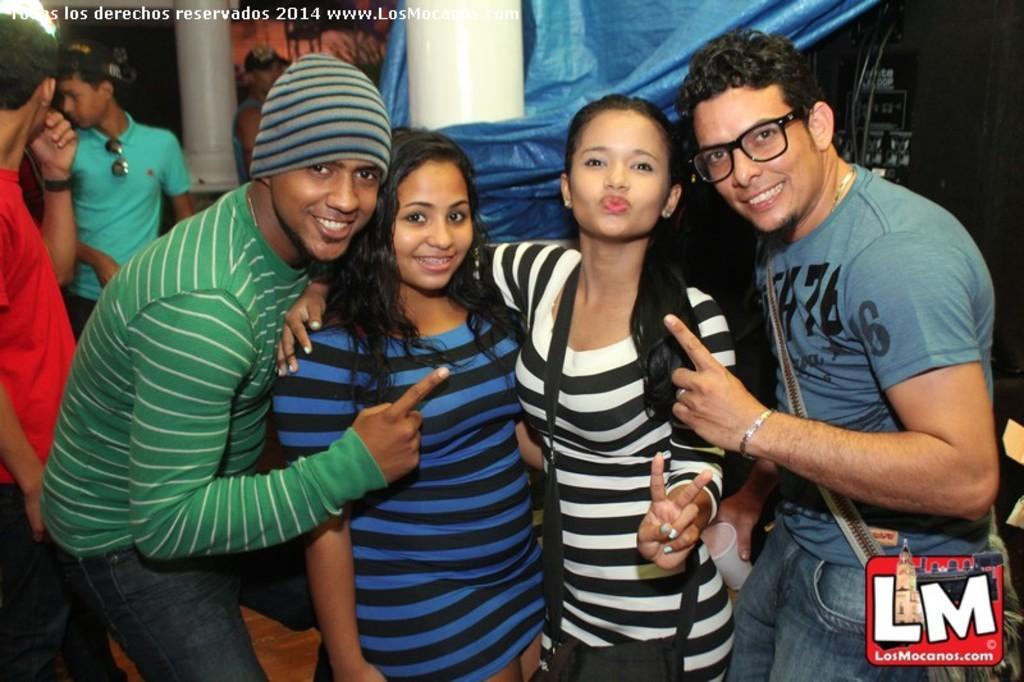Can you describe this image briefly? In the middle 2 beautiful girls are standing and smiling. On the right side a man is standing and showing his left hand index finger. He wore spectacles, t-shirt. 